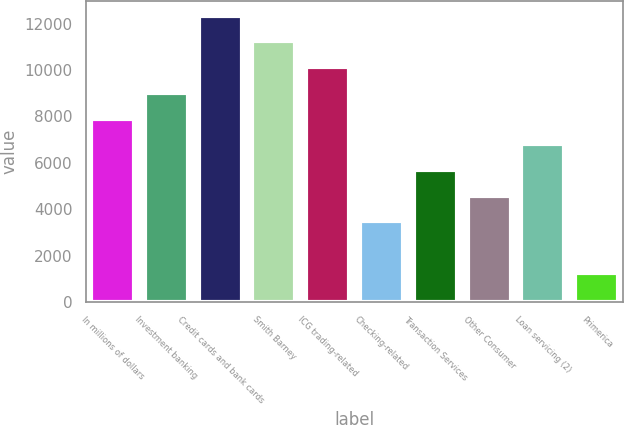Convert chart to OTSL. <chart><loc_0><loc_0><loc_500><loc_500><bar_chart><fcel>In millions of dollars<fcel>Investment banking<fcel>Credit cards and bank cards<fcel>Smith Barney<fcel>ICG trading-related<fcel>Checking-related<fcel>Transaction Services<fcel>Other Consumer<fcel>Loan servicing (2)<fcel>Primerica<nl><fcel>7901.2<fcel>9009.8<fcel>12335.6<fcel>11227<fcel>10118.4<fcel>3466.8<fcel>5684<fcel>4575.4<fcel>6792.6<fcel>1249.6<nl></chart> 